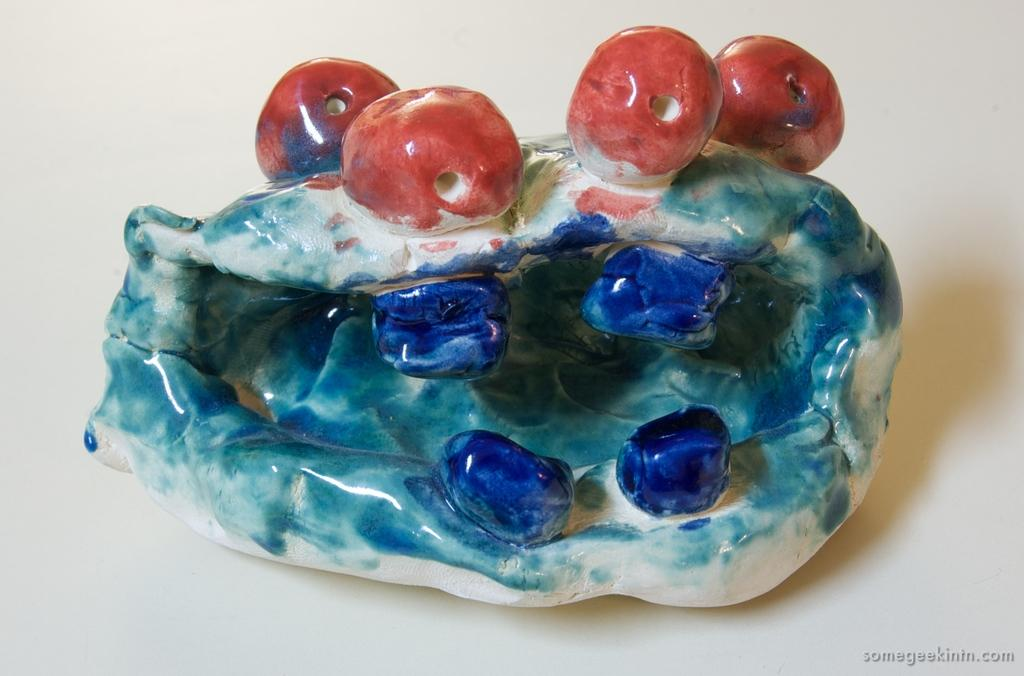What is the main subject in the center of the image? There is an object in the center of the image. Can you describe the object's location? The object is on a surface. Is there any text present in the image? Yes, there is text in the bottom right corner of the image. How many ducks are swimming in the mine in the image? There are no ducks or mines present in the image. What type of joke is being told by the object in the image? There is no joke being told in the image; it is a still image of an object on a surface with text in the bottom right corner. 